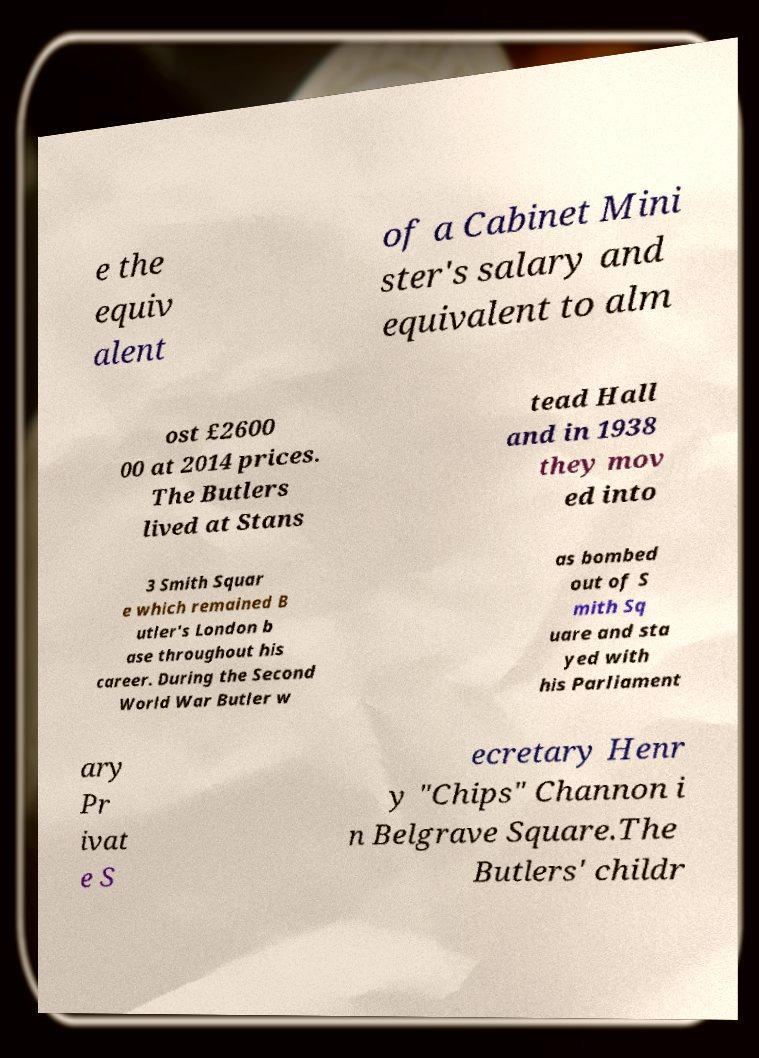Could you extract and type out the text from this image? e the equiv alent of a Cabinet Mini ster's salary and equivalent to alm ost £2600 00 at 2014 prices. The Butlers lived at Stans tead Hall and in 1938 they mov ed into 3 Smith Squar e which remained B utler's London b ase throughout his career. During the Second World War Butler w as bombed out of S mith Sq uare and sta yed with his Parliament ary Pr ivat e S ecretary Henr y "Chips" Channon i n Belgrave Square.The Butlers' childr 